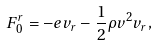<formula> <loc_0><loc_0><loc_500><loc_500>F _ { 0 } ^ { r } = - e v _ { r } - \frac { 1 } { 2 } \rho v ^ { 2 } v _ { r } ,</formula> 